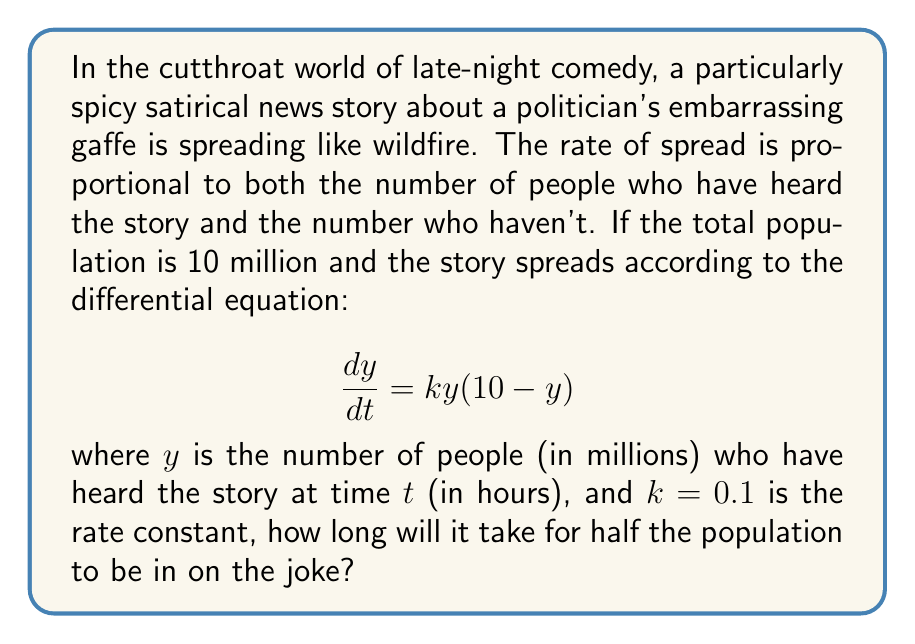Show me your answer to this math problem. Let's approach this step-by-step:

1) We need to solve the given differential equation:
   $$\frac{dy}{dt} = 0.1y(10 - y)$$

2) This is a separable differential equation. We can rewrite it as:
   $$\frac{dy}{y(10-y)} = 0.1dt$$

3) Integrating both sides:
   $$\int \frac{dy}{y(10-y)} = \int 0.1dt$$

4) The left side can be integrated using partial fractions:
   $$\frac{1}{10}(\frac{1}{y} + \frac{1}{10-y}) = 0.1t + C$$

5) Simplifying and solving for $y$:
   $$y = \frac{10}{1 + 9e^{-t}}$$

6) Now, we want to find $t$ when $y = 5$ (half the population):
   $$5 = \frac{10}{1 + 9e^{-t}}$$

7) Solving for $t$:
   $$1 + 9e^{-t} = 2$$
   $$9e^{-t} = 1$$
   $$e^{-t} = \frac{1}{9}$$
   $$-t = \ln(\frac{1}{9}) = -\ln(9)$$
   $$t = \ln(9)$$

8) Converting to hours:
   $$t = \frac{\ln(9)}{0.1} \approx 22.04$$

Thus, it will take approximately 22.04 hours for half the population to hear the story.
Answer: $t \approx 22.04$ hours 